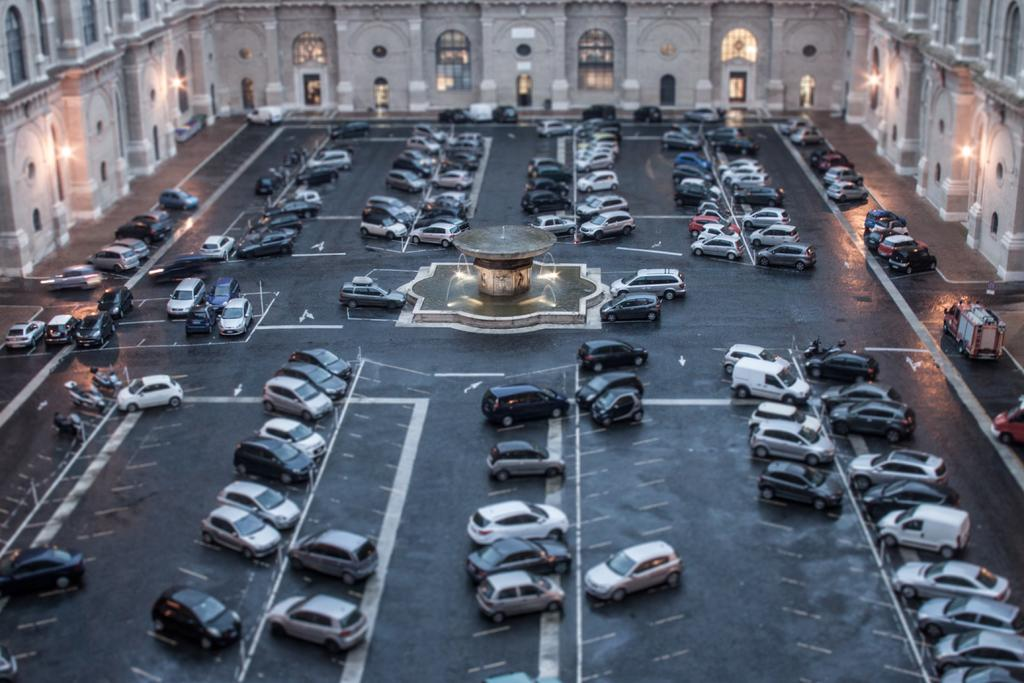What type of structure is visible in the image? There is a building in the image. What is located in the middle of the image? There is a fountain in the middle of the image. What can be seen on the road in the image? There are vehicles on the road in the image. What is attached to the wall in the image? There are lights on the wall in the image. What type of bread is being served at the meat counter in the image? There is no bread or meat counter present in the image; it features a building, a fountain, vehicles on the road, and lights on the wall. 